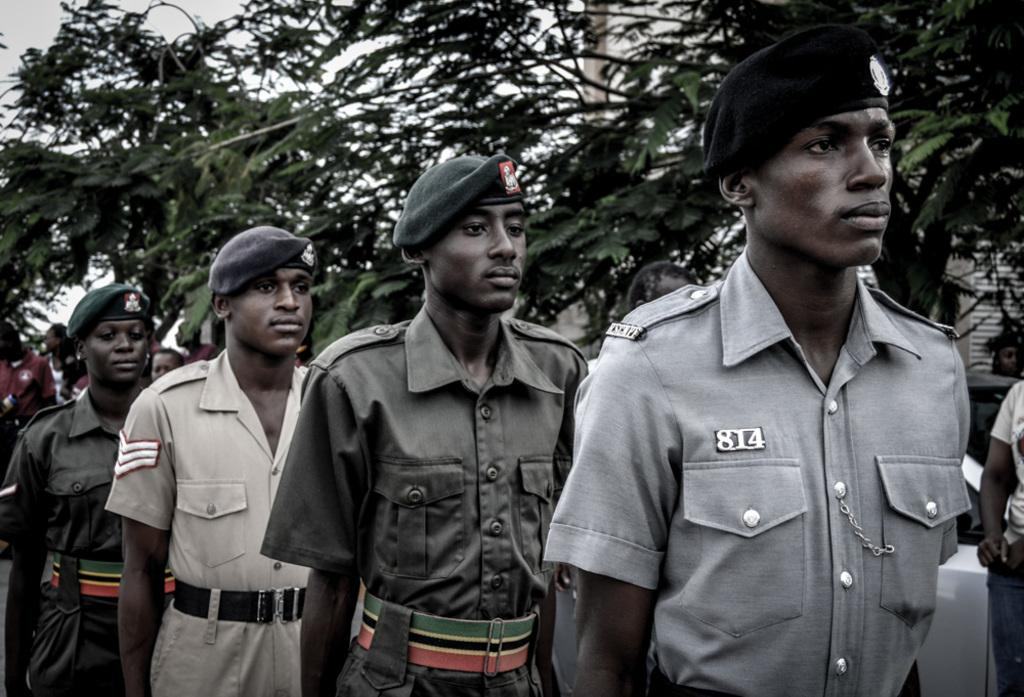How many people are present in the image? There are four persons standing in the image. Can you describe the group of people in the image? There is a group of people in the image, consisting of four persons. What else can be seen in the image besides the people? There is a vehicle, a building, trees, and the sky visible in the image. What type of grain is being harvested by the people in the image? There is no grain or harvesting activity depicted in the image. 